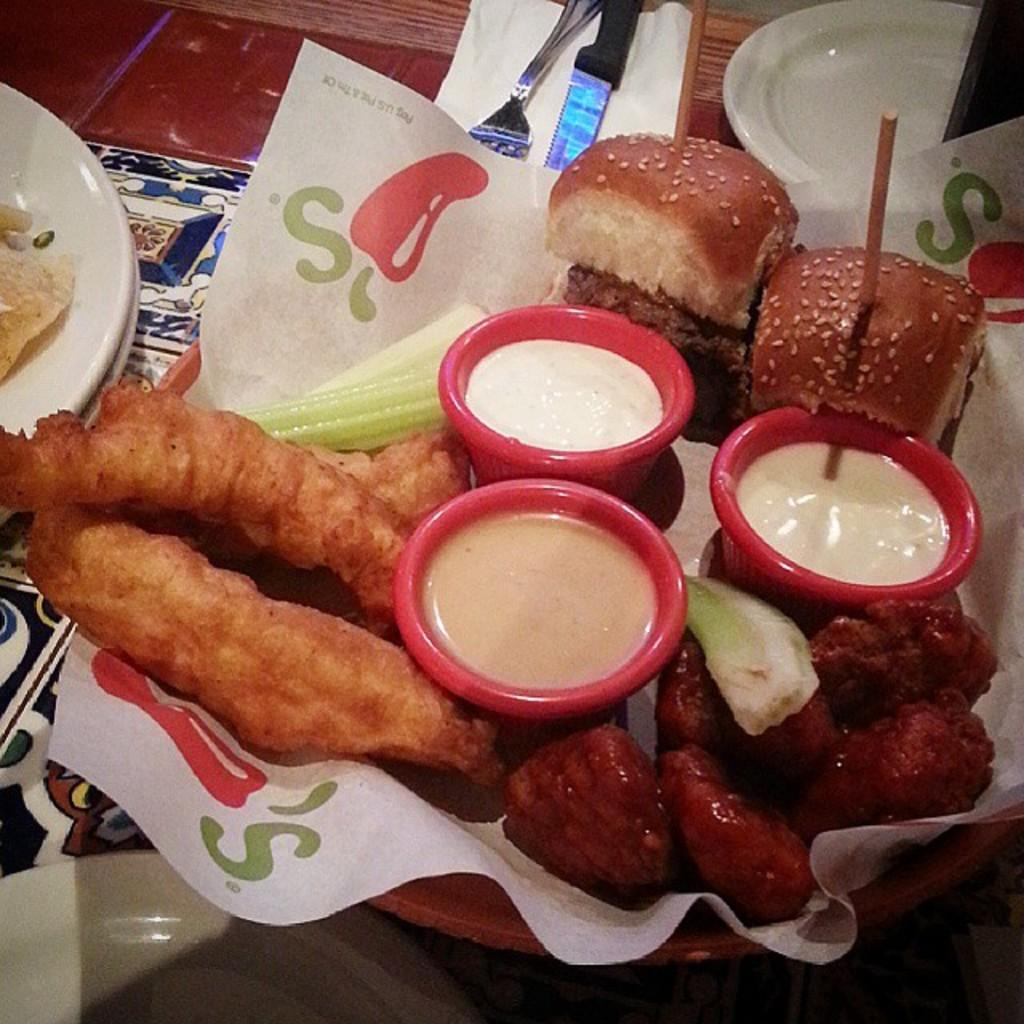What is the main object in the center of the image? There is a table in the center of the image. What items can be seen on the table? There are plates, forks, knives, tissue paper, a cloth, a bowl containing food items with paper, and three cups on the table. What type of dinosaur can be seen sitting on the table in the image? There are no dinosaurs present in the image; the table is set with plates, forks, knives, tissue paper, a cloth, a bowl containing food items with paper, and three cups. Can you hear a whistle in the image? There is no mention of a whistle in the image, and no sound can be heard from a static image. 